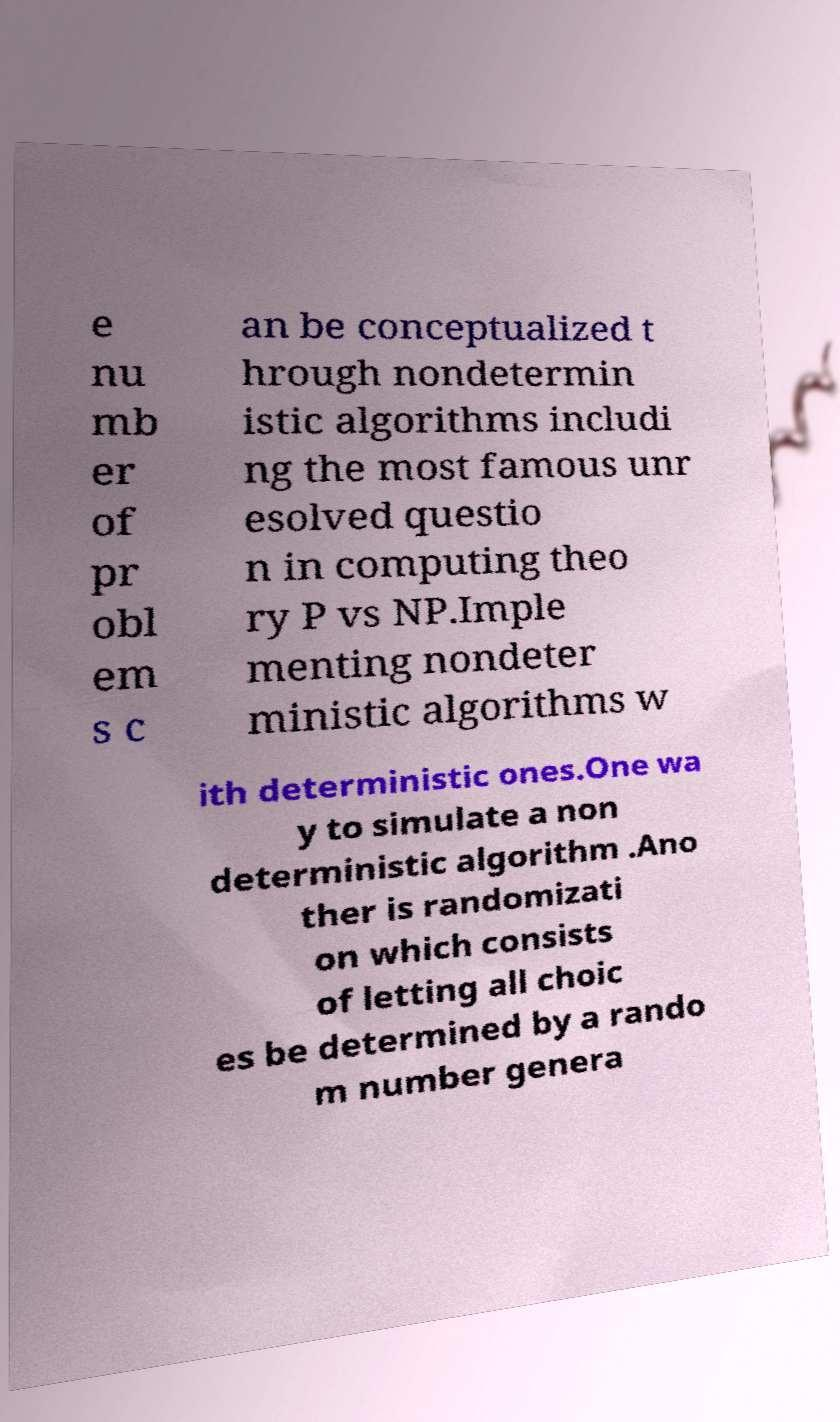What messages or text are displayed in this image? I need them in a readable, typed format. e nu mb er of pr obl em s c an be conceptualized t hrough nondetermin istic algorithms includi ng the most famous unr esolved questio n in computing theo ry P vs NP.Imple menting nondeter ministic algorithms w ith deterministic ones.One wa y to simulate a non deterministic algorithm .Ano ther is randomizati on which consists of letting all choic es be determined by a rando m number genera 